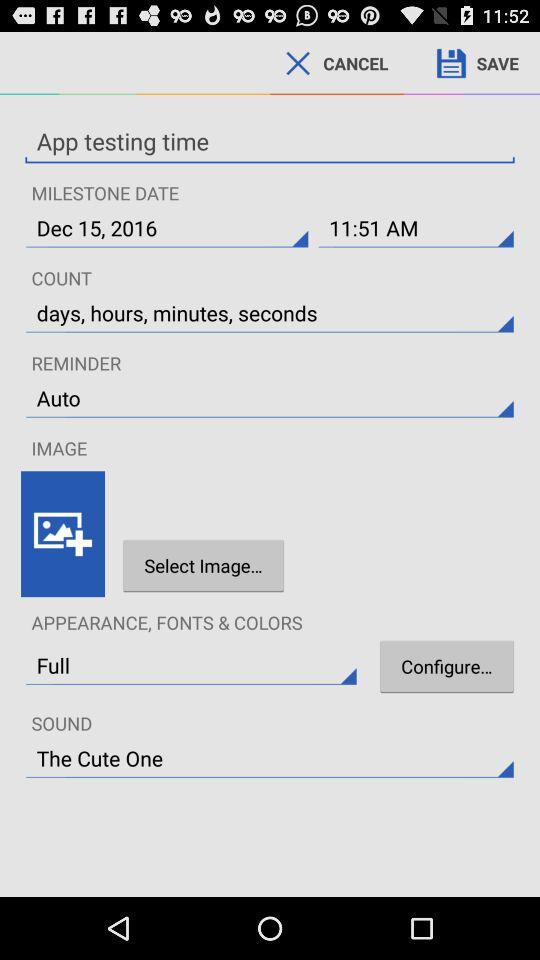What is the selected option in "APPEARANCE, FONTS & COLORS"? The selected option is "Full". 